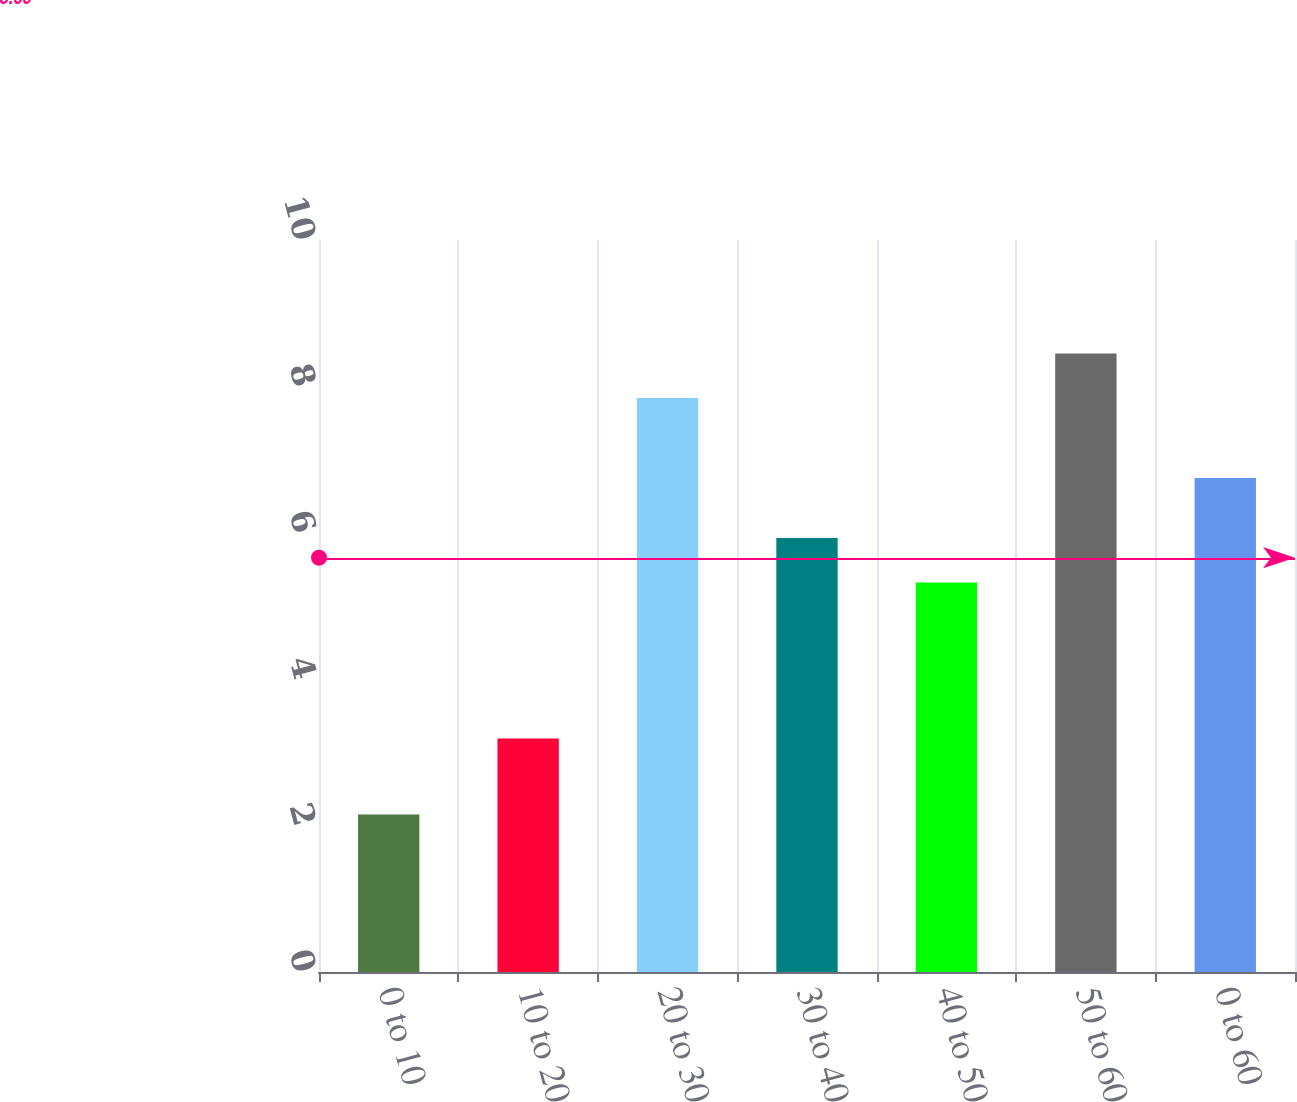Convert chart to OTSL. <chart><loc_0><loc_0><loc_500><loc_500><bar_chart><fcel>0 to 10<fcel>10 to 20<fcel>20 to 30<fcel>30 to 40<fcel>40 to 50<fcel>50 to 60<fcel>0 to 60<nl><fcel>2.15<fcel>3.19<fcel>7.84<fcel>5.93<fcel>5.32<fcel>8.45<fcel>6.75<nl></chart> 